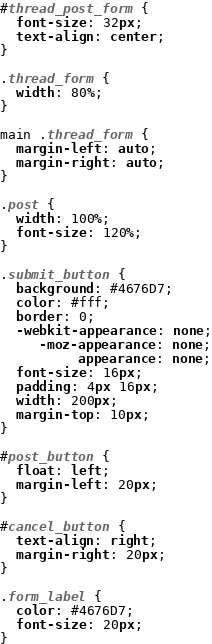<code> <loc_0><loc_0><loc_500><loc_500><_CSS_>#thread_post_form {
  font-size: 32px;
  text-align: center;
}

.thread_form {
  width: 80%;
}

main .thread_form {
  margin-left: auto;
  margin-right: auto;
}

.post {
  width: 100%;
  font-size: 120%;
}

.submit_button {
  background: #4676D7;
  color: #fff;
  border: 0;
  -webkit-appearance: none;
     -moz-appearance: none;
          appearance: none;
  font-size: 16px;
  padding: 4px 16px;
  width: 200px;
  margin-top: 10px;
}

#post_button {
  float: left;
  margin-left: 20px;
}

#cancel_button {
  text-align: right;
  margin-right: 20px;
}

.form_label {
  color: #4676D7;
  font-size: 20px;
}
</code> 